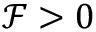<formula> <loc_0><loc_0><loc_500><loc_500>\mathcal { F } > 0</formula> 